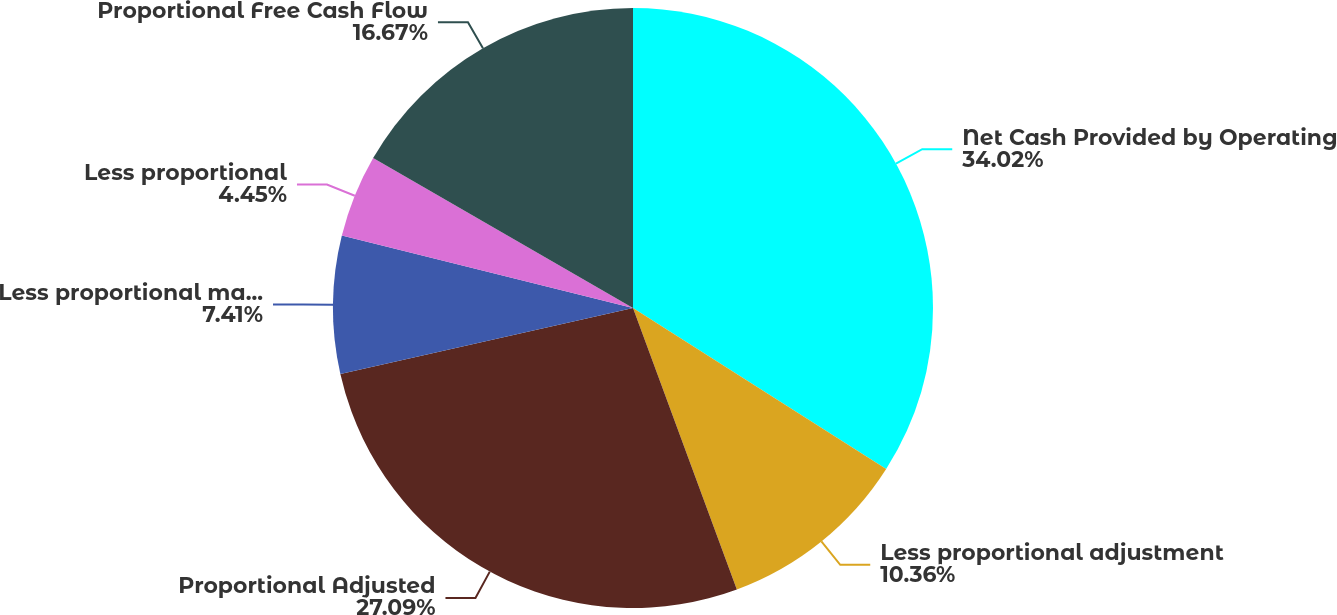Convert chart. <chart><loc_0><loc_0><loc_500><loc_500><pie_chart><fcel>Net Cash Provided by Operating<fcel>Less proportional adjustment<fcel>Proportional Adjusted<fcel>Less proportional maintenance<fcel>Less proportional<fcel>Proportional Free Cash Flow<nl><fcel>34.01%<fcel>10.36%<fcel>27.09%<fcel>7.41%<fcel>4.45%<fcel>16.67%<nl></chart> 